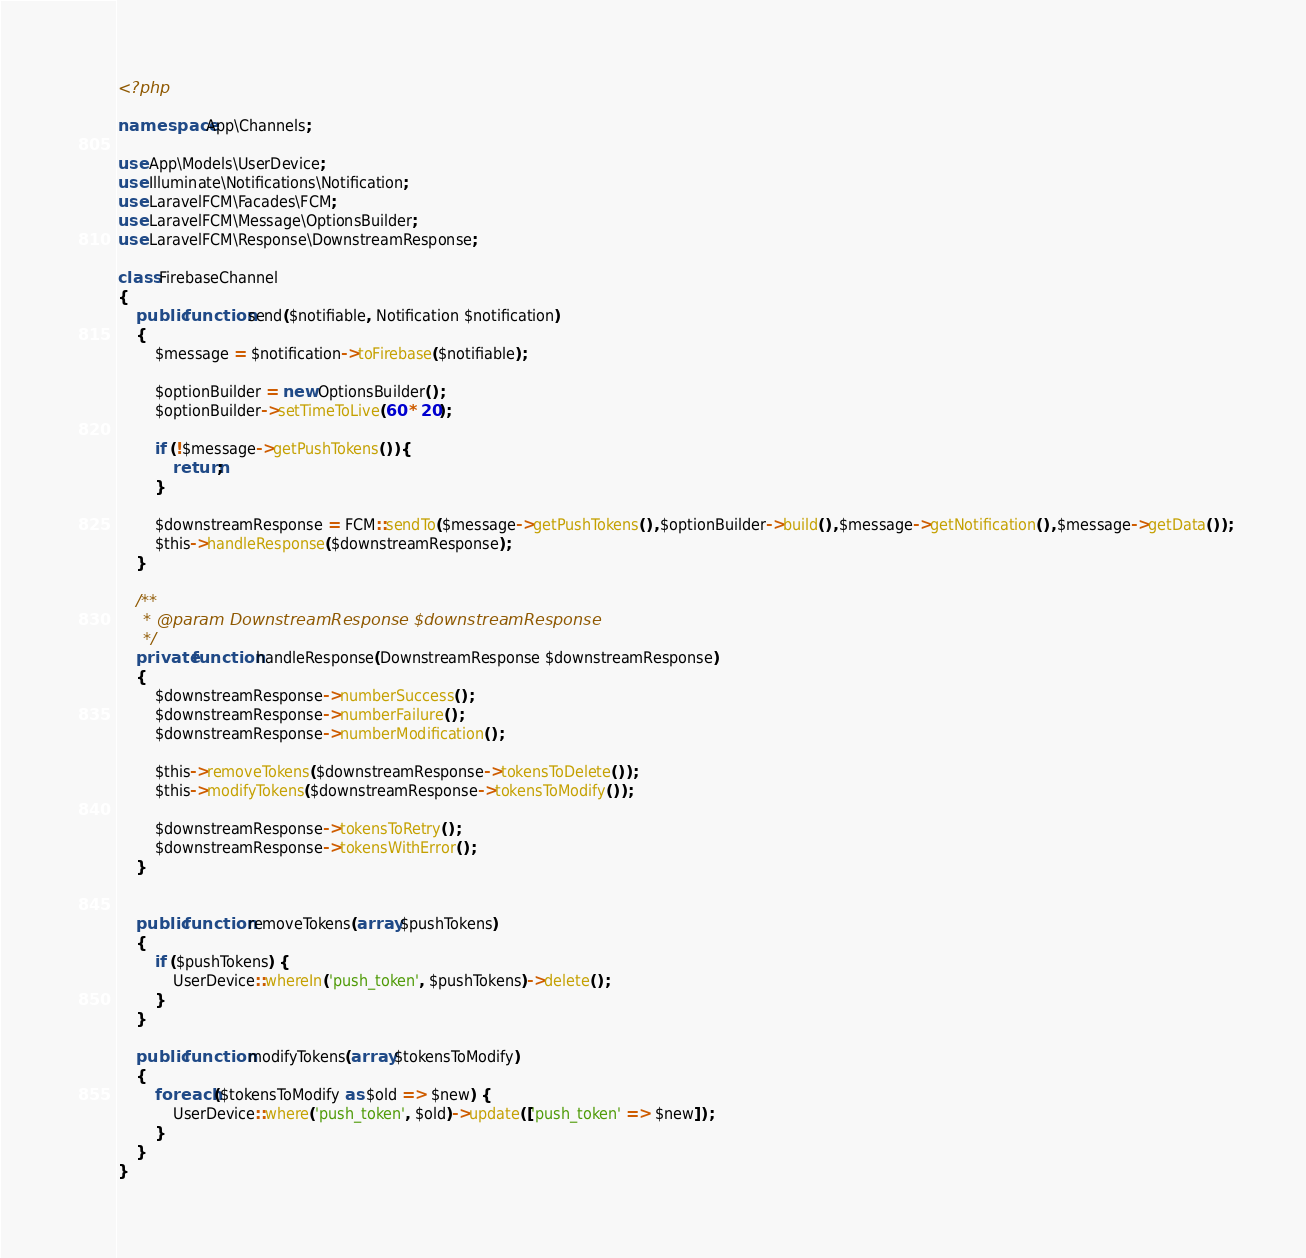Convert code to text. <code><loc_0><loc_0><loc_500><loc_500><_PHP_><?php

namespace App\Channels;

use App\Models\UserDevice;
use Illuminate\Notifications\Notification;
use LaravelFCM\Facades\FCM;
use LaravelFCM\Message\OptionsBuilder;
use LaravelFCM\Response\DownstreamResponse;

class FirebaseChannel
{
    public function send($notifiable, Notification $notification)
    {
        $message = $notification->toFirebase($notifiable);

        $optionBuilder = new OptionsBuilder();
        $optionBuilder->setTimeToLive(60 * 20);

        if (!$message->getPushTokens()) {
            return;
        }

        $downstreamResponse = FCM::sendTo($message->getPushTokens(), $optionBuilder->build(), $message->getNotification(), $message->getData());
        $this->handleResponse($downstreamResponse);
    }

    /**
     * @param DownstreamResponse $downstreamResponse
     */
    private function handleResponse(DownstreamResponse $downstreamResponse)
    {
        $downstreamResponse->numberSuccess();
        $downstreamResponse->numberFailure();
        $downstreamResponse->numberModification();

        $this->removeTokens($downstreamResponse->tokensToDelete());
        $this->modifyTokens($downstreamResponse->tokensToModify());

        $downstreamResponse->tokensToRetry();
        $downstreamResponse->tokensWithError();
    }


    public function removeTokens(array $pushTokens)
    {
        if ($pushTokens) {
            UserDevice::whereIn('push_token', $pushTokens)->delete();
        }
    }

    public function modifyTokens(array $tokensToModify)
    {
        foreach ($tokensToModify as $old => $new) {
            UserDevice::where('push_token', $old)->update(['push_token' => $new]);
        }
    }
}
</code> 